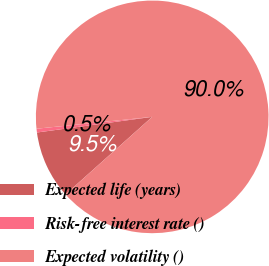<chart> <loc_0><loc_0><loc_500><loc_500><pie_chart><fcel>Expected life (years)<fcel>Risk-free interest rate ()<fcel>Expected volatility ()<nl><fcel>9.47%<fcel>0.52%<fcel>90.01%<nl></chart> 